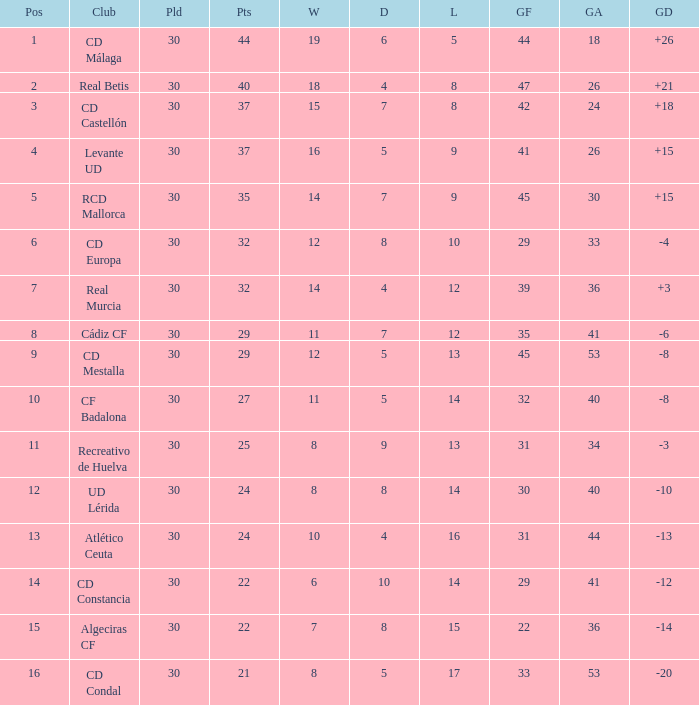What is the number of losses when the goal difference was -8, and position is smaller than 10? 1.0. 